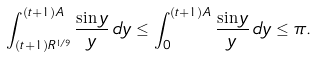<formula> <loc_0><loc_0><loc_500><loc_500>\int _ { ( t + 1 ) R ^ { 1 / 9 } } ^ { ( t + 1 ) A } \frac { \sin y } { y } \, d y \leq \int _ { 0 } ^ { ( t + 1 ) A } \frac { \sin y } { y } \, d y \leq \pi .</formula> 